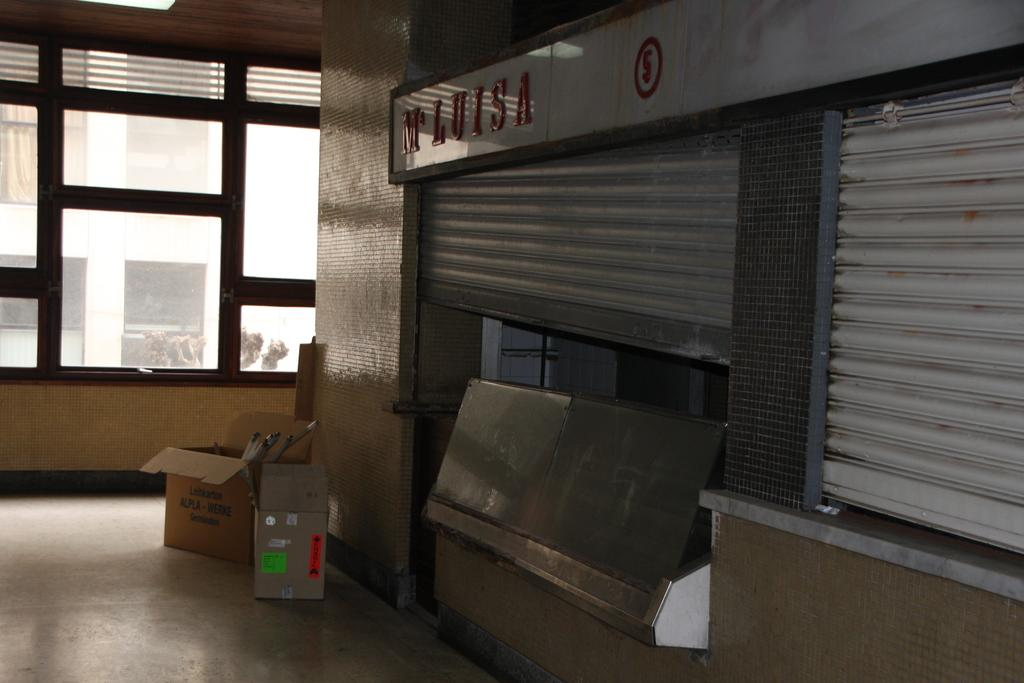What type of window covering can be seen in the image? There are shutters in the image. What is located near the shutters? There is a stall with a name board in the image. What type of containers are present in the image? Cardboard boxes are present in the image. What can be seen in the background of the image? There is a building in the background of the image. What type of legal advice is the lawyer offering in the image? There is no lawyer present in the image, so no legal advice can be offered. What type of stick can be seen leaning against the stall in the image? There is no stick present in the image; only shutters, a stall with a name board, cardboard boxes, a window, and a building in the background are visible. 